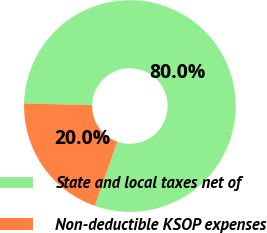Convert chart. <chart><loc_0><loc_0><loc_500><loc_500><pie_chart><fcel>State and local taxes net of<fcel>Non-deductible KSOP expenses<nl><fcel>80.0%<fcel>20.0%<nl></chart> 